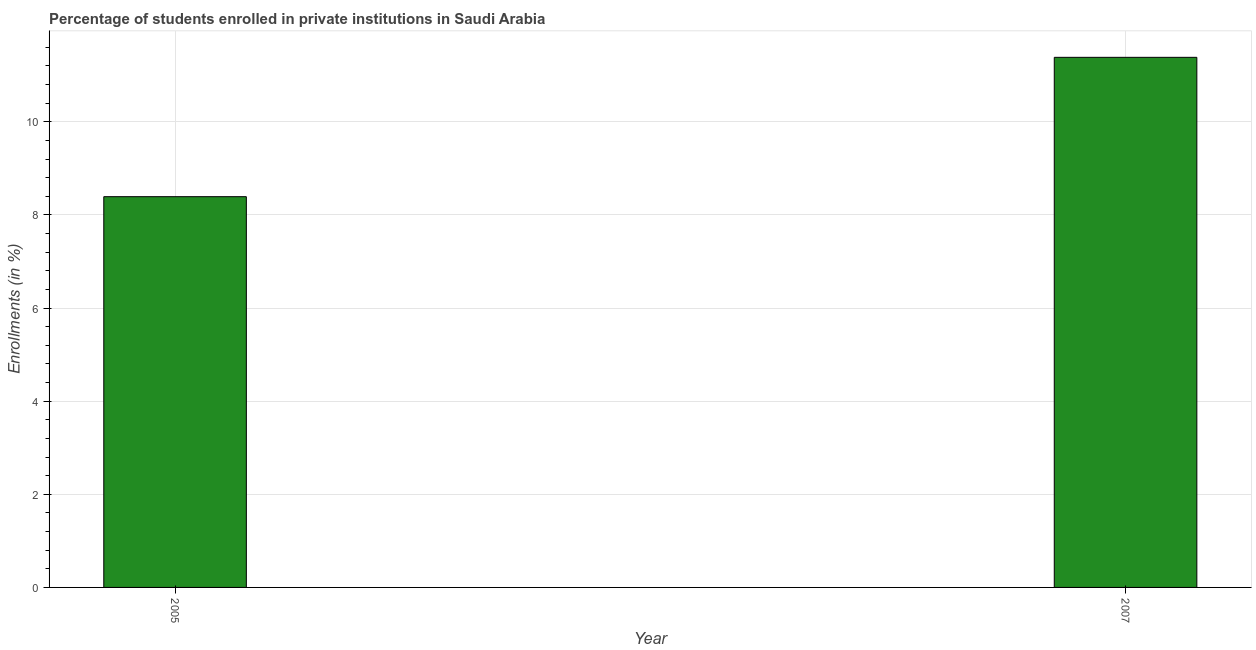What is the title of the graph?
Your answer should be compact. Percentage of students enrolled in private institutions in Saudi Arabia. What is the label or title of the X-axis?
Your response must be concise. Year. What is the label or title of the Y-axis?
Keep it short and to the point. Enrollments (in %). What is the enrollments in private institutions in 2005?
Provide a succinct answer. 8.39. Across all years, what is the maximum enrollments in private institutions?
Your answer should be compact. 11.39. Across all years, what is the minimum enrollments in private institutions?
Ensure brevity in your answer.  8.39. In which year was the enrollments in private institutions maximum?
Offer a very short reply. 2007. What is the sum of the enrollments in private institutions?
Offer a terse response. 19.78. What is the difference between the enrollments in private institutions in 2005 and 2007?
Your answer should be very brief. -2.99. What is the average enrollments in private institutions per year?
Make the answer very short. 9.89. What is the median enrollments in private institutions?
Offer a very short reply. 9.89. Do a majority of the years between 2007 and 2005 (inclusive) have enrollments in private institutions greater than 8.4 %?
Provide a short and direct response. No. What is the ratio of the enrollments in private institutions in 2005 to that in 2007?
Provide a short and direct response. 0.74. Is the enrollments in private institutions in 2005 less than that in 2007?
Offer a very short reply. Yes. In how many years, is the enrollments in private institutions greater than the average enrollments in private institutions taken over all years?
Your answer should be very brief. 1. How many bars are there?
Give a very brief answer. 2. What is the difference between two consecutive major ticks on the Y-axis?
Provide a short and direct response. 2. Are the values on the major ticks of Y-axis written in scientific E-notation?
Your answer should be very brief. No. What is the Enrollments (in %) in 2005?
Ensure brevity in your answer.  8.39. What is the Enrollments (in %) in 2007?
Provide a succinct answer. 11.39. What is the difference between the Enrollments (in %) in 2005 and 2007?
Keep it short and to the point. -2.99. What is the ratio of the Enrollments (in %) in 2005 to that in 2007?
Ensure brevity in your answer.  0.74. 